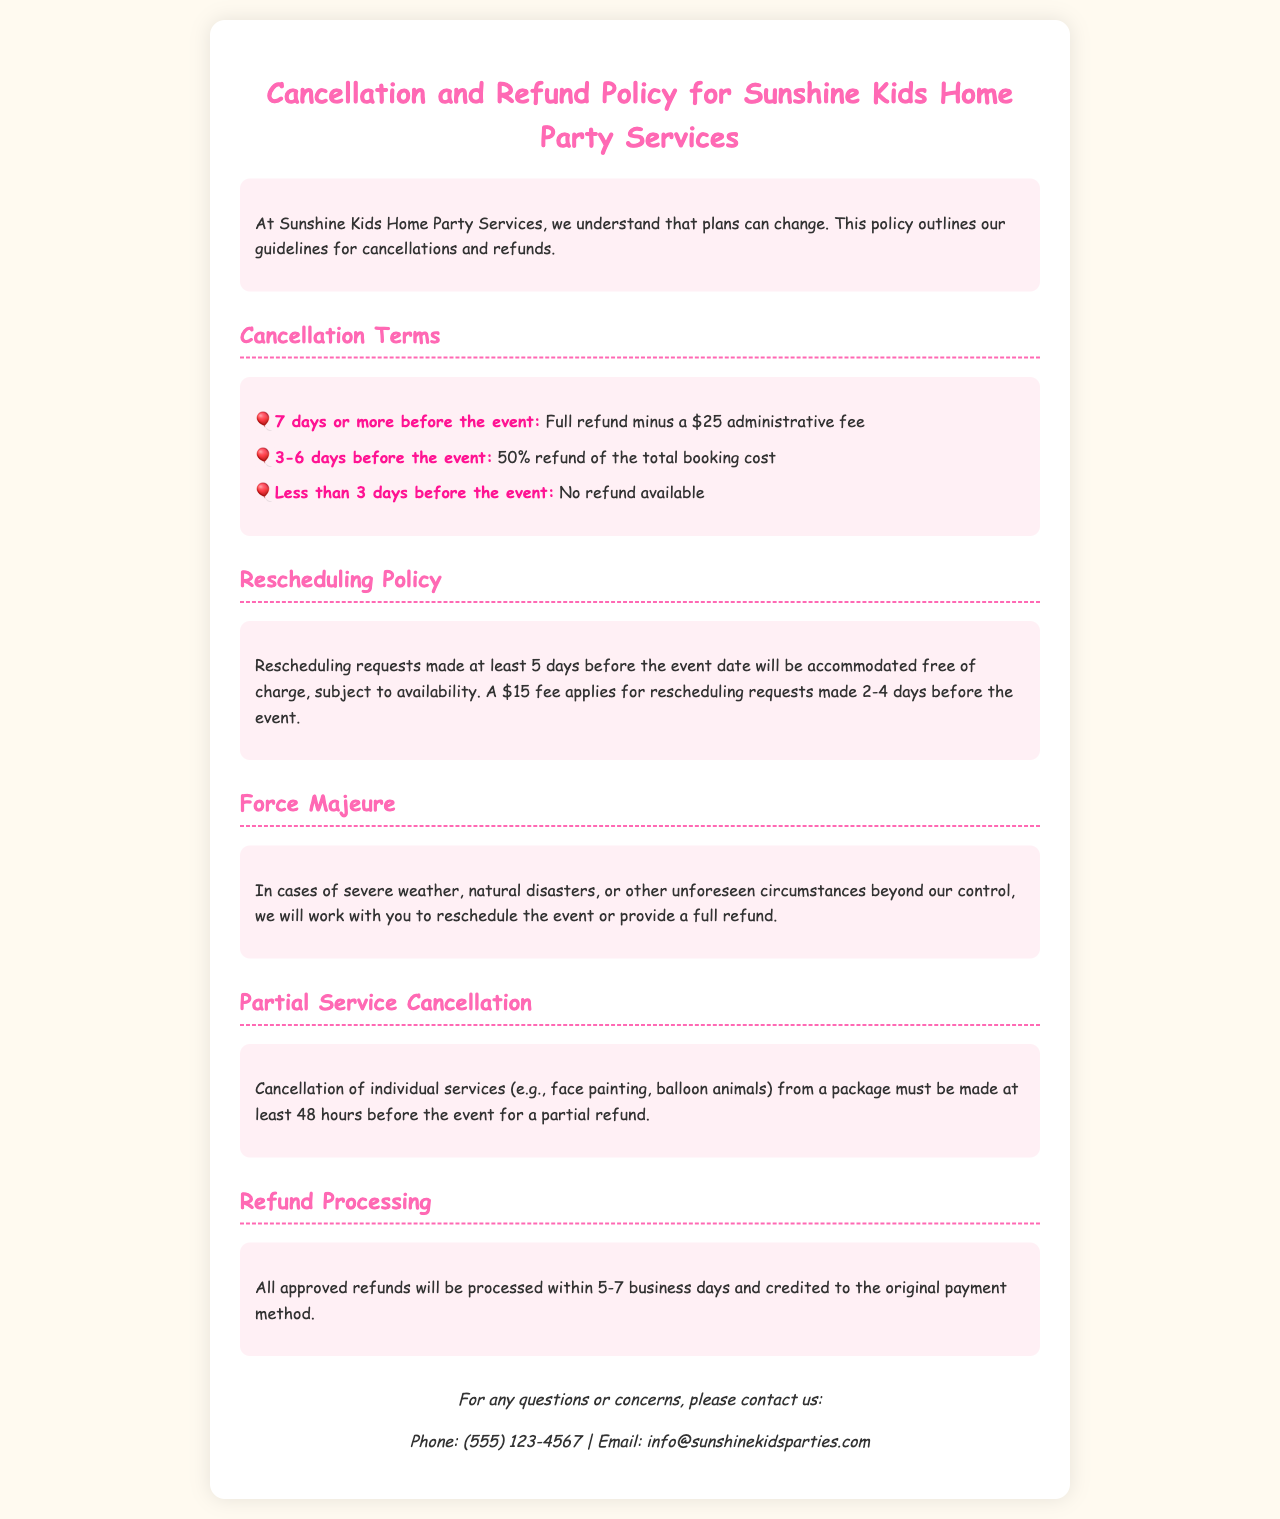What is the administrative fee for a cancellation? The administrative fee for a cancellation is stated in the document under "Cancellation Terms" and is $25.
Answer: $25 What percentage is refunded for cancellations made 3-6 days before the event? This information is specified under the "Cancellation Terms" section as 50% refund of the total booking cost.
Answer: 50% How many days in advance do you need to cancel for a full refund? The policy states that a full refund can be obtained by cancelling 7 days or more before the event.
Answer: 7 days What is the fee for rescheduling made 2-4 days before the event? The document mentions a fee of $15 for rescheduling requests made 2-4 days before the event.
Answer: $15 What happens in the case of severe weather? The document indicates that in cases of severe weather, the company will work with you to reschedule the event or provide a full refund.
Answer: Reschedule or full refund What is the timeframe for processing approved refunds? The time for processing approved refunds is mentioned in the "Refund Processing" section as 5-7 business days.
Answer: 5-7 business days What must be done for a partial refund on individual services? The document states that cancellation of individual services must be made at least 48 hours before the event for a partial refund.
Answer: 48 hours 